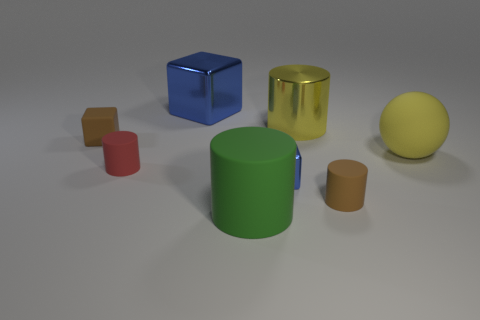There is a rubber thing that is both to the left of the big green thing and behind the small red matte thing; what is its shape?
Your response must be concise. Cube. What size is the green object that is the same shape as the red matte thing?
Provide a succinct answer. Large. Is the number of brown matte cylinders that are on the right side of the big yellow rubber ball less than the number of green matte spheres?
Offer a very short reply. No. There is a blue metal thing behind the big rubber sphere; how big is it?
Offer a terse response. Large. What is the color of the big matte thing that is the same shape as the yellow metal thing?
Keep it short and to the point. Green. What number of tiny cylinders are the same color as the large metallic block?
Give a very brief answer. 0. Are there any other things that have the same shape as the big yellow matte object?
Ensure brevity in your answer.  No. Is there a brown rubber cylinder behind the large rubber thing behind the matte cylinder behind the small blue block?
Make the answer very short. No. What number of other brown cubes are the same material as the brown block?
Make the answer very short. 0. Does the blue shiny thing that is in front of the metal cylinder have the same size as the brown thing that is in front of the red cylinder?
Your answer should be very brief. Yes. 